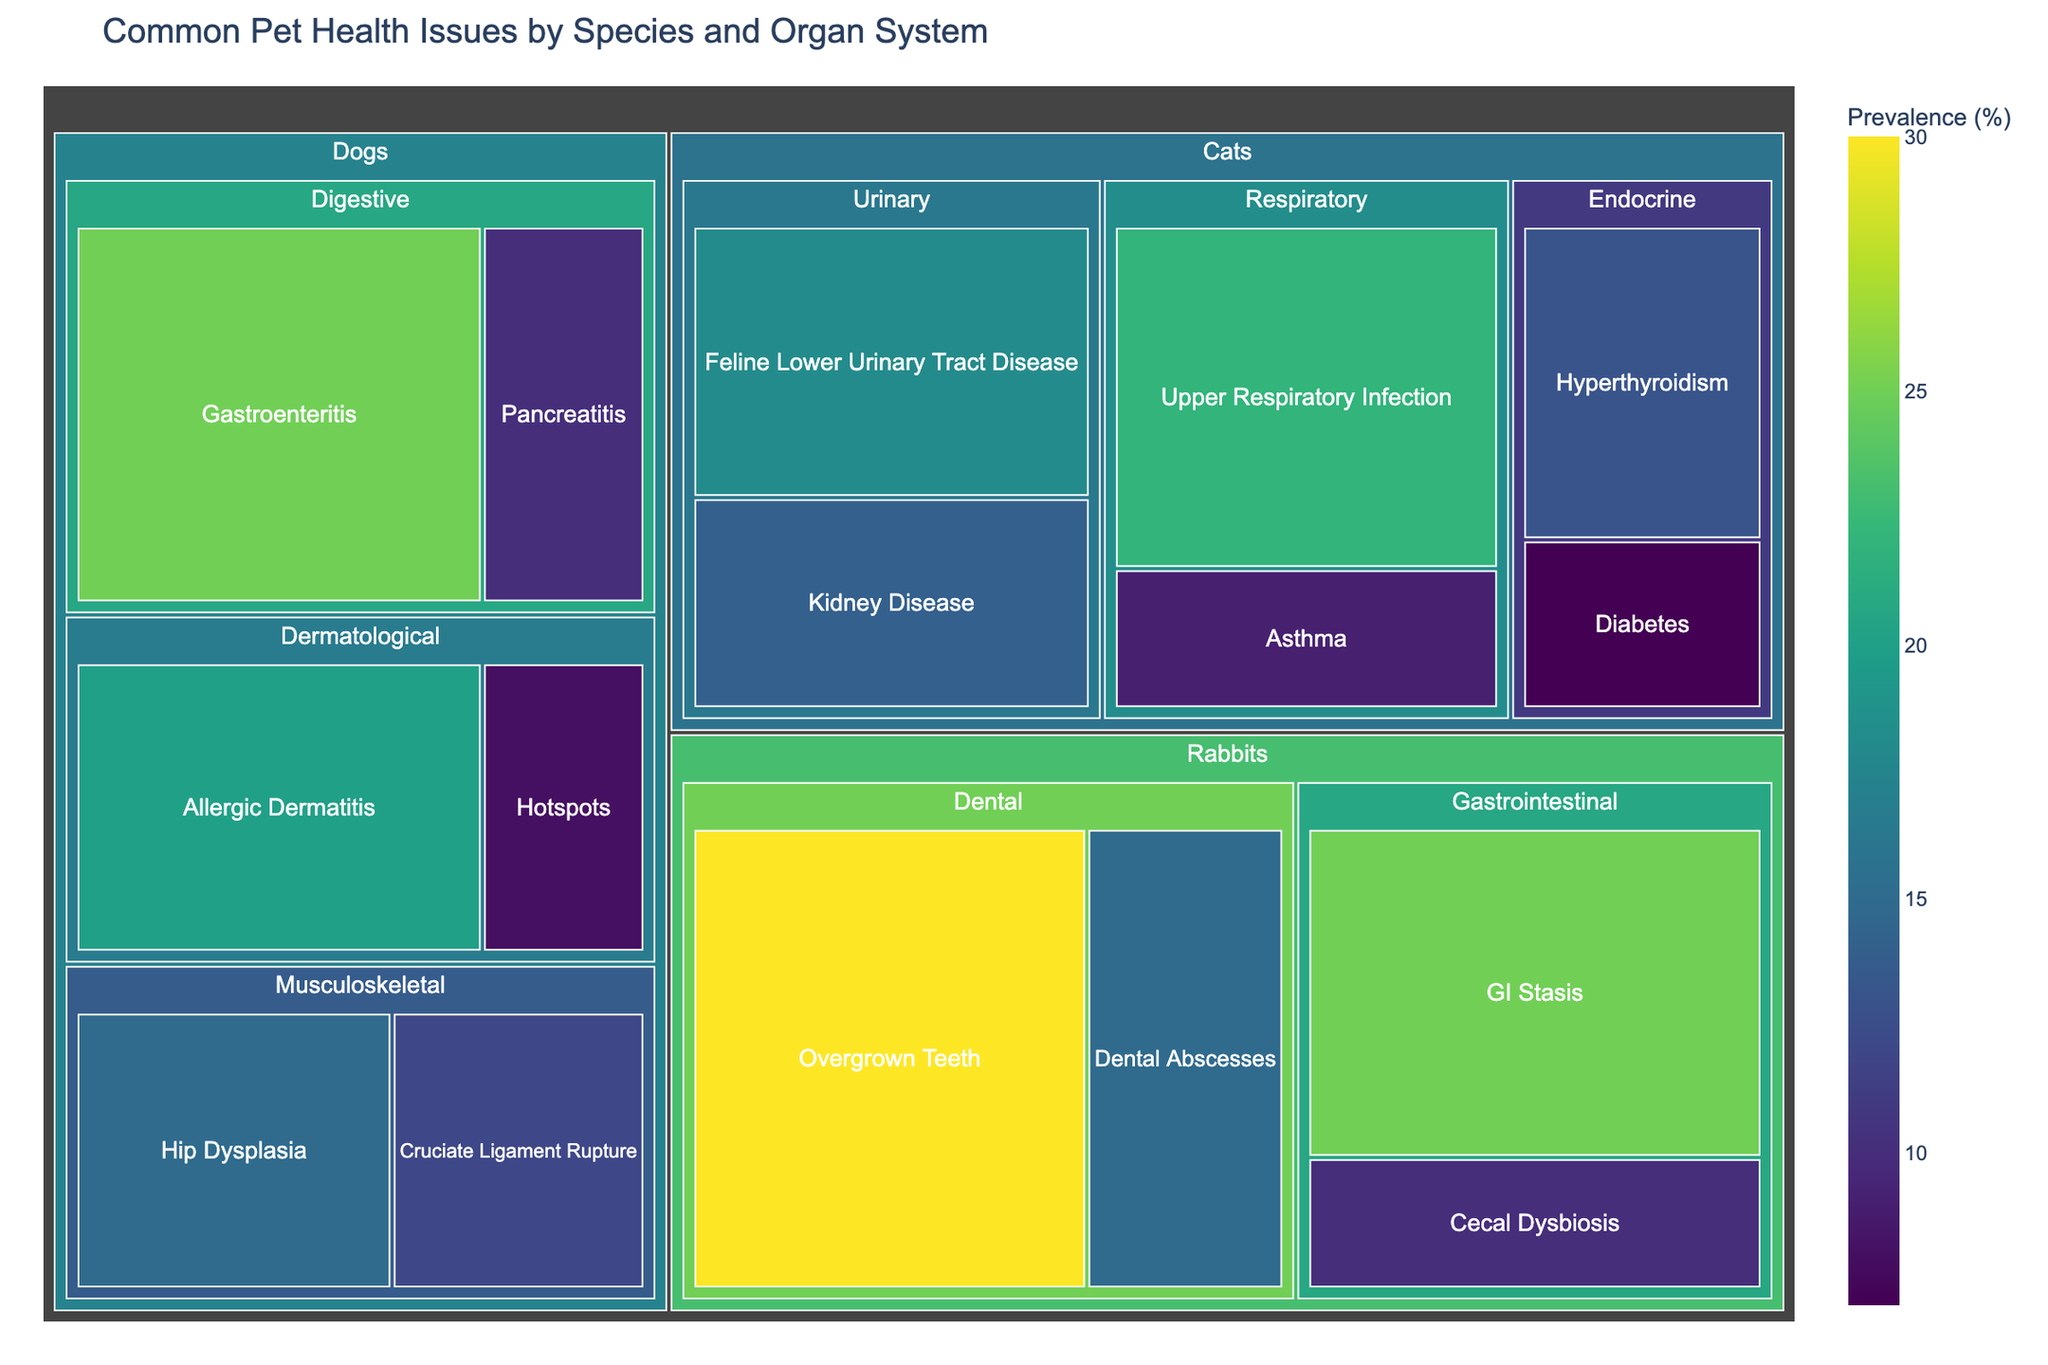Which species has the highest prevalence of health issues in the Digestive category? Observe the Treemap and locate the Digestive category within each species. Compare the individual values of prevalence. Dogs in the Digestive category have Gastroenteritis with 25% and Pancreatitis with 10%, totaling 35%. Rabbits have Overgrown Teeth at 30%. Thus, dogs have a combined higher total in the Digestive category.
Answer: Dogs What is the combined prevalence of respiratory diseases in cats? Sum the individual prevalence values of the health issues in the Respiratory category for cats. Cats have Upper Respiratory Infection (22%) and Asthma (9%). Combined prevalence is 22% + 9% = 31%.
Answer: 31% Which organ system in rabbits has the largest total prevalence of health issues? Sum the prevalence of health issues within each organ system in rabbits. Dental has Overgrown Teeth (30%) and Dental Abscesses (15%) totaling 45%. Gastrointestinal has GI Stasis (25%) and Cecal Dysbiosis (10%) totaling 35%. Dental has the largest total prevalence.
Answer: Dental Which health issue has the highest prevalence among all species and organ systems? Locate all health issues across different species and organ systems and identify the one with the highest prevalence. Overgrown Teeth in rabbits has the highest prevalence at 30%.
Answer: Overgrown Teeth How does the prevalence of Hyperthyroidism in cats compare to Gastroenteritis in dogs? Compare the prevalence values of Hyperthyroidism (13%) in cats to Gastroenteritis (25%) in dogs. Gastroenteritis in dogs has a higher prevalence.
Answer: Gastroenteritis is higher What is the total prevalence of musculoskeletal health issues in dogs? Sum the prevalence of musculoskeletal health issues in dogs. Hip Dysplasia (15%) and Cruciate Ligament Rupture (12%). The total is 15% + 12% = 27%.
Answer: 27% Are there more digestive or dental health issues in rabbits based on prevalence? Compare the total prevalences of digestive and dental health issues in rabbits. Digestive (GI Stasis 25% + Cecal Dysbiosis 10%) totals 35%. Dental (Overgrown Teeth 30% + Dental Abscesses 15%) totals 45%. Dental health issues are more prevalent.
Answer: Dental Which species has the most varied organ systems affected by health issues? Count the number of unique organ systems affected by health issues within each species. Dogs have issues in Digestive, Musculoskeletal, Dermatological systems (3). Cats have issues in Urinary, Respiratory, Endocrine systems (3). Rabbits have issues in Dental and Gastrointestinal systems (2). Both dogs and cats have 3 organ systems affected.
Answer: Dogs and Cats 